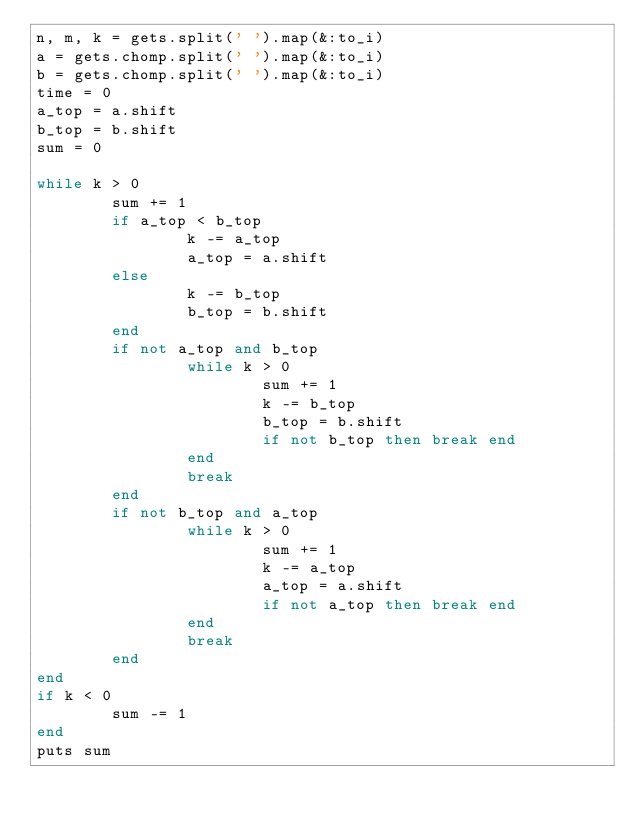Convert code to text. <code><loc_0><loc_0><loc_500><loc_500><_Ruby_>n, m, k = gets.split(' ').map(&:to_i)
a = gets.chomp.split(' ').map(&:to_i)
b = gets.chomp.split(' ').map(&:to_i)
time = 0
a_top = a.shift
b_top = b.shift
sum = 0

while k > 0
        sum += 1
        if a_top < b_top
                k -= a_top
                a_top = a.shift
        else
                k -= b_top
                b_top = b.shift
        end
        if not a_top and b_top
                while k > 0
                        sum += 1
                        k -= b_top
                        b_top = b.shift
                        if not b_top then break end
                end
                break
        end
        if not b_top and a_top
                while k > 0
                        sum += 1
                        k -= a_top
                        a_top = a.shift
                        if not a_top then break end
                end
                break
        end
end
if k < 0
        sum -= 1
end
puts sum</code> 